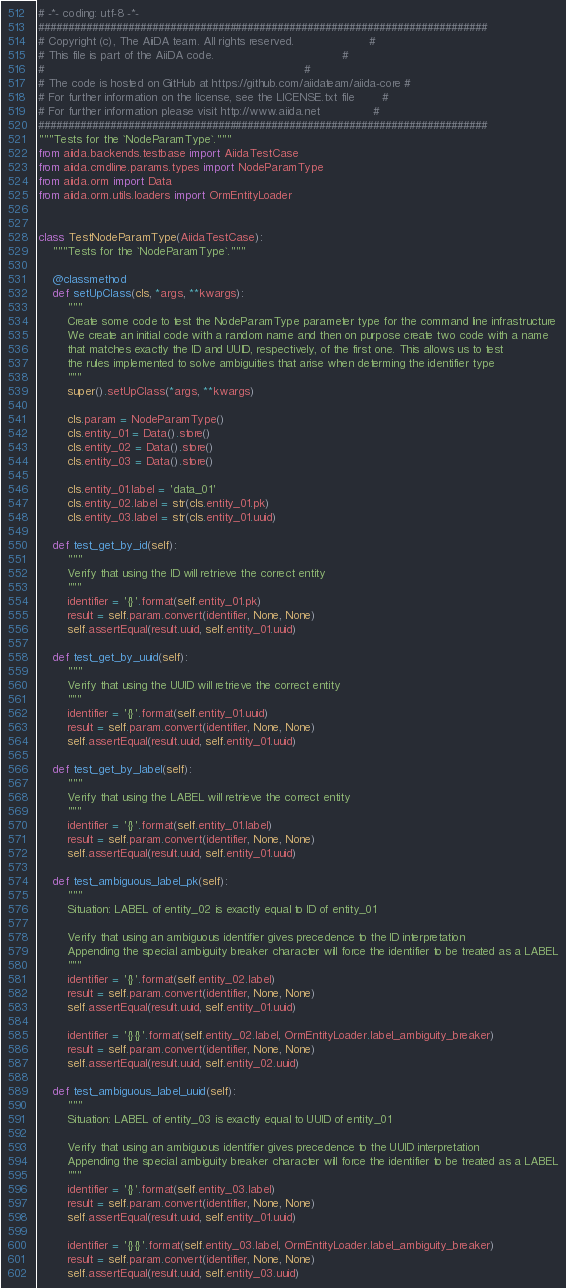Convert code to text. <code><loc_0><loc_0><loc_500><loc_500><_Python_># -*- coding: utf-8 -*-
###########################################################################
# Copyright (c), The AiiDA team. All rights reserved.                     #
# This file is part of the AiiDA code.                                    #
#                                                                         #
# The code is hosted on GitHub at https://github.com/aiidateam/aiida-core #
# For further information on the license, see the LICENSE.txt file        #
# For further information please visit http://www.aiida.net               #
###########################################################################
"""Tests for the `NodeParamType`."""
from aiida.backends.testbase import AiidaTestCase
from aiida.cmdline.params.types import NodeParamType
from aiida.orm import Data
from aiida.orm.utils.loaders import OrmEntityLoader


class TestNodeParamType(AiidaTestCase):
    """Tests for the `NodeParamType`."""

    @classmethod
    def setUpClass(cls, *args, **kwargs):
        """
        Create some code to test the NodeParamType parameter type for the command line infrastructure
        We create an initial code with a random name and then on purpose create two code with a name
        that matches exactly the ID and UUID, respectively, of the first one. This allows us to test
        the rules implemented to solve ambiguities that arise when determing the identifier type
        """
        super().setUpClass(*args, **kwargs)

        cls.param = NodeParamType()
        cls.entity_01 = Data().store()
        cls.entity_02 = Data().store()
        cls.entity_03 = Data().store()

        cls.entity_01.label = 'data_01'
        cls.entity_02.label = str(cls.entity_01.pk)
        cls.entity_03.label = str(cls.entity_01.uuid)

    def test_get_by_id(self):
        """
        Verify that using the ID will retrieve the correct entity
        """
        identifier = '{}'.format(self.entity_01.pk)
        result = self.param.convert(identifier, None, None)
        self.assertEqual(result.uuid, self.entity_01.uuid)

    def test_get_by_uuid(self):
        """
        Verify that using the UUID will retrieve the correct entity
        """
        identifier = '{}'.format(self.entity_01.uuid)
        result = self.param.convert(identifier, None, None)
        self.assertEqual(result.uuid, self.entity_01.uuid)

    def test_get_by_label(self):
        """
        Verify that using the LABEL will retrieve the correct entity
        """
        identifier = '{}'.format(self.entity_01.label)
        result = self.param.convert(identifier, None, None)
        self.assertEqual(result.uuid, self.entity_01.uuid)

    def test_ambiguous_label_pk(self):
        """
        Situation: LABEL of entity_02 is exactly equal to ID of entity_01

        Verify that using an ambiguous identifier gives precedence to the ID interpretation
        Appending the special ambiguity breaker character will force the identifier to be treated as a LABEL
        """
        identifier = '{}'.format(self.entity_02.label)
        result = self.param.convert(identifier, None, None)
        self.assertEqual(result.uuid, self.entity_01.uuid)

        identifier = '{}{}'.format(self.entity_02.label, OrmEntityLoader.label_ambiguity_breaker)
        result = self.param.convert(identifier, None, None)
        self.assertEqual(result.uuid, self.entity_02.uuid)

    def test_ambiguous_label_uuid(self):
        """
        Situation: LABEL of entity_03 is exactly equal to UUID of entity_01

        Verify that using an ambiguous identifier gives precedence to the UUID interpretation
        Appending the special ambiguity breaker character will force the identifier to be treated as a LABEL
        """
        identifier = '{}'.format(self.entity_03.label)
        result = self.param.convert(identifier, None, None)
        self.assertEqual(result.uuid, self.entity_01.uuid)

        identifier = '{}{}'.format(self.entity_03.label, OrmEntityLoader.label_ambiguity_breaker)
        result = self.param.convert(identifier, None, None)
        self.assertEqual(result.uuid, self.entity_03.uuid)
</code> 